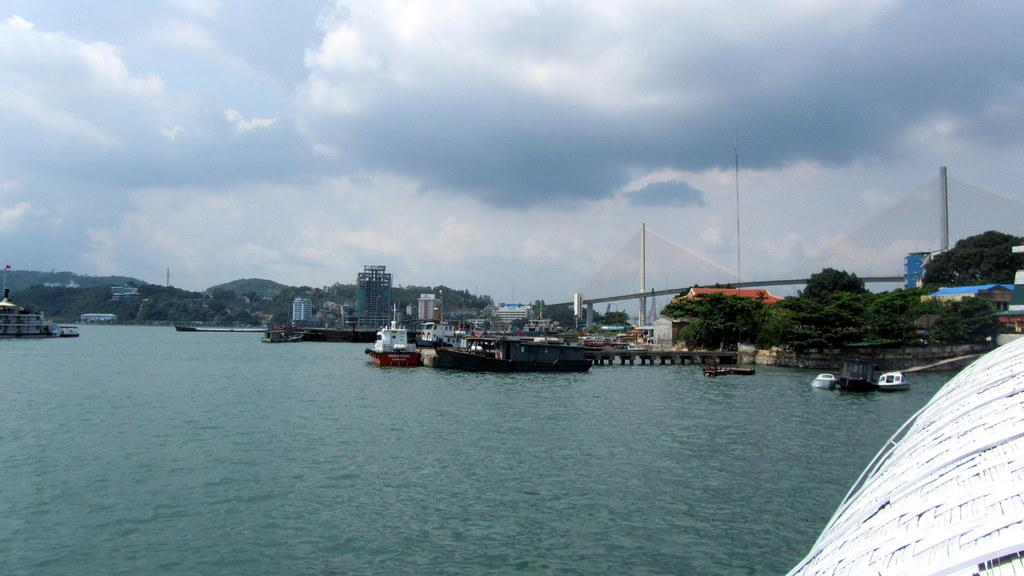What types of vehicles are in the water in the image? There are boats and ships in the water in the image. What can be seen in the background of the image? There are trees, sheds, buildings, and poles in the background. What is visible in the sky at the top of the image? There are clouds in the sky at the top of the image. What type of yard can be seen in the image? There is no yard present in the image; it features boats and ships in the water, as well as various structures and objects in the background. What message is being conveyed by the people saying good-bye in the image? There are no people saying good-bye in the image; it only shows boats, ships, and the surrounding environment. 